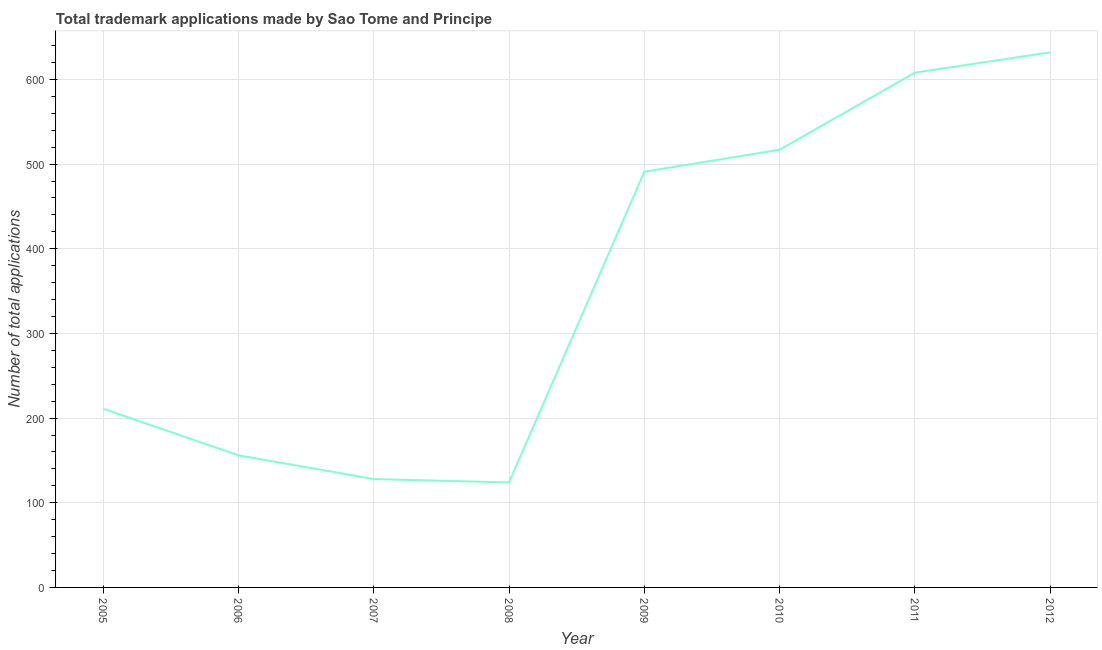What is the number of trademark applications in 2005?
Keep it short and to the point. 211. Across all years, what is the maximum number of trademark applications?
Your answer should be compact. 632. Across all years, what is the minimum number of trademark applications?
Give a very brief answer. 124. In which year was the number of trademark applications maximum?
Keep it short and to the point. 2012. In which year was the number of trademark applications minimum?
Ensure brevity in your answer.  2008. What is the sum of the number of trademark applications?
Your response must be concise. 2867. What is the difference between the number of trademark applications in 2011 and 2012?
Keep it short and to the point. -24. What is the average number of trademark applications per year?
Your answer should be compact. 358.38. What is the median number of trademark applications?
Provide a succinct answer. 351. What is the ratio of the number of trademark applications in 2005 to that in 2006?
Offer a very short reply. 1.35. Is the number of trademark applications in 2005 less than that in 2009?
Ensure brevity in your answer.  Yes. Is the difference between the number of trademark applications in 2006 and 2010 greater than the difference between any two years?
Keep it short and to the point. No. What is the difference between the highest and the lowest number of trademark applications?
Your answer should be very brief. 508. Are the values on the major ticks of Y-axis written in scientific E-notation?
Provide a succinct answer. No. Does the graph contain any zero values?
Your response must be concise. No. Does the graph contain grids?
Keep it short and to the point. Yes. What is the title of the graph?
Provide a succinct answer. Total trademark applications made by Sao Tome and Principe. What is the label or title of the Y-axis?
Your answer should be compact. Number of total applications. What is the Number of total applications of 2005?
Your answer should be compact. 211. What is the Number of total applications of 2006?
Provide a short and direct response. 156. What is the Number of total applications of 2007?
Offer a terse response. 128. What is the Number of total applications in 2008?
Offer a very short reply. 124. What is the Number of total applications of 2009?
Your answer should be compact. 491. What is the Number of total applications of 2010?
Offer a terse response. 517. What is the Number of total applications of 2011?
Offer a terse response. 608. What is the Number of total applications in 2012?
Ensure brevity in your answer.  632. What is the difference between the Number of total applications in 2005 and 2007?
Your response must be concise. 83. What is the difference between the Number of total applications in 2005 and 2008?
Provide a succinct answer. 87. What is the difference between the Number of total applications in 2005 and 2009?
Ensure brevity in your answer.  -280. What is the difference between the Number of total applications in 2005 and 2010?
Your answer should be compact. -306. What is the difference between the Number of total applications in 2005 and 2011?
Make the answer very short. -397. What is the difference between the Number of total applications in 2005 and 2012?
Ensure brevity in your answer.  -421. What is the difference between the Number of total applications in 2006 and 2007?
Your answer should be very brief. 28. What is the difference between the Number of total applications in 2006 and 2009?
Your answer should be very brief. -335. What is the difference between the Number of total applications in 2006 and 2010?
Offer a terse response. -361. What is the difference between the Number of total applications in 2006 and 2011?
Your response must be concise. -452. What is the difference between the Number of total applications in 2006 and 2012?
Give a very brief answer. -476. What is the difference between the Number of total applications in 2007 and 2008?
Offer a terse response. 4. What is the difference between the Number of total applications in 2007 and 2009?
Provide a succinct answer. -363. What is the difference between the Number of total applications in 2007 and 2010?
Make the answer very short. -389. What is the difference between the Number of total applications in 2007 and 2011?
Ensure brevity in your answer.  -480. What is the difference between the Number of total applications in 2007 and 2012?
Your answer should be very brief. -504. What is the difference between the Number of total applications in 2008 and 2009?
Provide a succinct answer. -367. What is the difference between the Number of total applications in 2008 and 2010?
Offer a very short reply. -393. What is the difference between the Number of total applications in 2008 and 2011?
Your response must be concise. -484. What is the difference between the Number of total applications in 2008 and 2012?
Make the answer very short. -508. What is the difference between the Number of total applications in 2009 and 2010?
Your answer should be compact. -26. What is the difference between the Number of total applications in 2009 and 2011?
Ensure brevity in your answer.  -117. What is the difference between the Number of total applications in 2009 and 2012?
Your response must be concise. -141. What is the difference between the Number of total applications in 2010 and 2011?
Provide a succinct answer. -91. What is the difference between the Number of total applications in 2010 and 2012?
Make the answer very short. -115. What is the ratio of the Number of total applications in 2005 to that in 2006?
Provide a short and direct response. 1.35. What is the ratio of the Number of total applications in 2005 to that in 2007?
Make the answer very short. 1.65. What is the ratio of the Number of total applications in 2005 to that in 2008?
Your response must be concise. 1.7. What is the ratio of the Number of total applications in 2005 to that in 2009?
Offer a very short reply. 0.43. What is the ratio of the Number of total applications in 2005 to that in 2010?
Offer a very short reply. 0.41. What is the ratio of the Number of total applications in 2005 to that in 2011?
Give a very brief answer. 0.35. What is the ratio of the Number of total applications in 2005 to that in 2012?
Offer a terse response. 0.33. What is the ratio of the Number of total applications in 2006 to that in 2007?
Keep it short and to the point. 1.22. What is the ratio of the Number of total applications in 2006 to that in 2008?
Keep it short and to the point. 1.26. What is the ratio of the Number of total applications in 2006 to that in 2009?
Your response must be concise. 0.32. What is the ratio of the Number of total applications in 2006 to that in 2010?
Offer a very short reply. 0.3. What is the ratio of the Number of total applications in 2006 to that in 2011?
Make the answer very short. 0.26. What is the ratio of the Number of total applications in 2006 to that in 2012?
Make the answer very short. 0.25. What is the ratio of the Number of total applications in 2007 to that in 2008?
Make the answer very short. 1.03. What is the ratio of the Number of total applications in 2007 to that in 2009?
Provide a short and direct response. 0.26. What is the ratio of the Number of total applications in 2007 to that in 2010?
Your response must be concise. 0.25. What is the ratio of the Number of total applications in 2007 to that in 2011?
Offer a terse response. 0.21. What is the ratio of the Number of total applications in 2007 to that in 2012?
Make the answer very short. 0.2. What is the ratio of the Number of total applications in 2008 to that in 2009?
Make the answer very short. 0.25. What is the ratio of the Number of total applications in 2008 to that in 2010?
Make the answer very short. 0.24. What is the ratio of the Number of total applications in 2008 to that in 2011?
Ensure brevity in your answer.  0.2. What is the ratio of the Number of total applications in 2008 to that in 2012?
Give a very brief answer. 0.2. What is the ratio of the Number of total applications in 2009 to that in 2011?
Your response must be concise. 0.81. What is the ratio of the Number of total applications in 2009 to that in 2012?
Give a very brief answer. 0.78. What is the ratio of the Number of total applications in 2010 to that in 2012?
Your answer should be very brief. 0.82. 